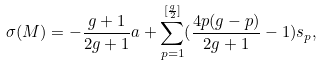Convert formula to latex. <formula><loc_0><loc_0><loc_500><loc_500>\sigma ( M ) = - \frac { g + 1 } { 2 g + 1 } a + \sum _ { p = 1 } ^ { [ \frac { g } { 2 } ] } ( \frac { 4 p ( g - p ) } { 2 g + 1 } - 1 ) s _ { p } ,</formula> 